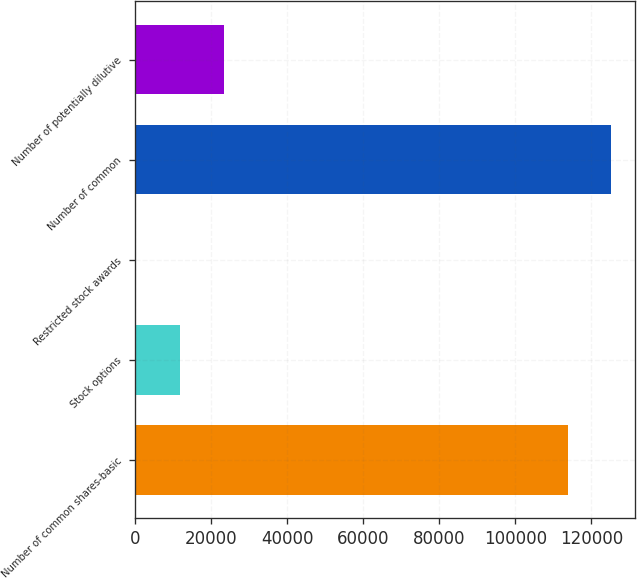Convert chart to OTSL. <chart><loc_0><loc_0><loc_500><loc_500><bar_chart><fcel>Number of common shares-basic<fcel>Stock options<fcel>Restricted stock awards<fcel>Number of common<fcel>Number of potentially dilutive<nl><fcel>113728<fcel>11742.5<fcel>285<fcel>125186<fcel>23200<nl></chart> 